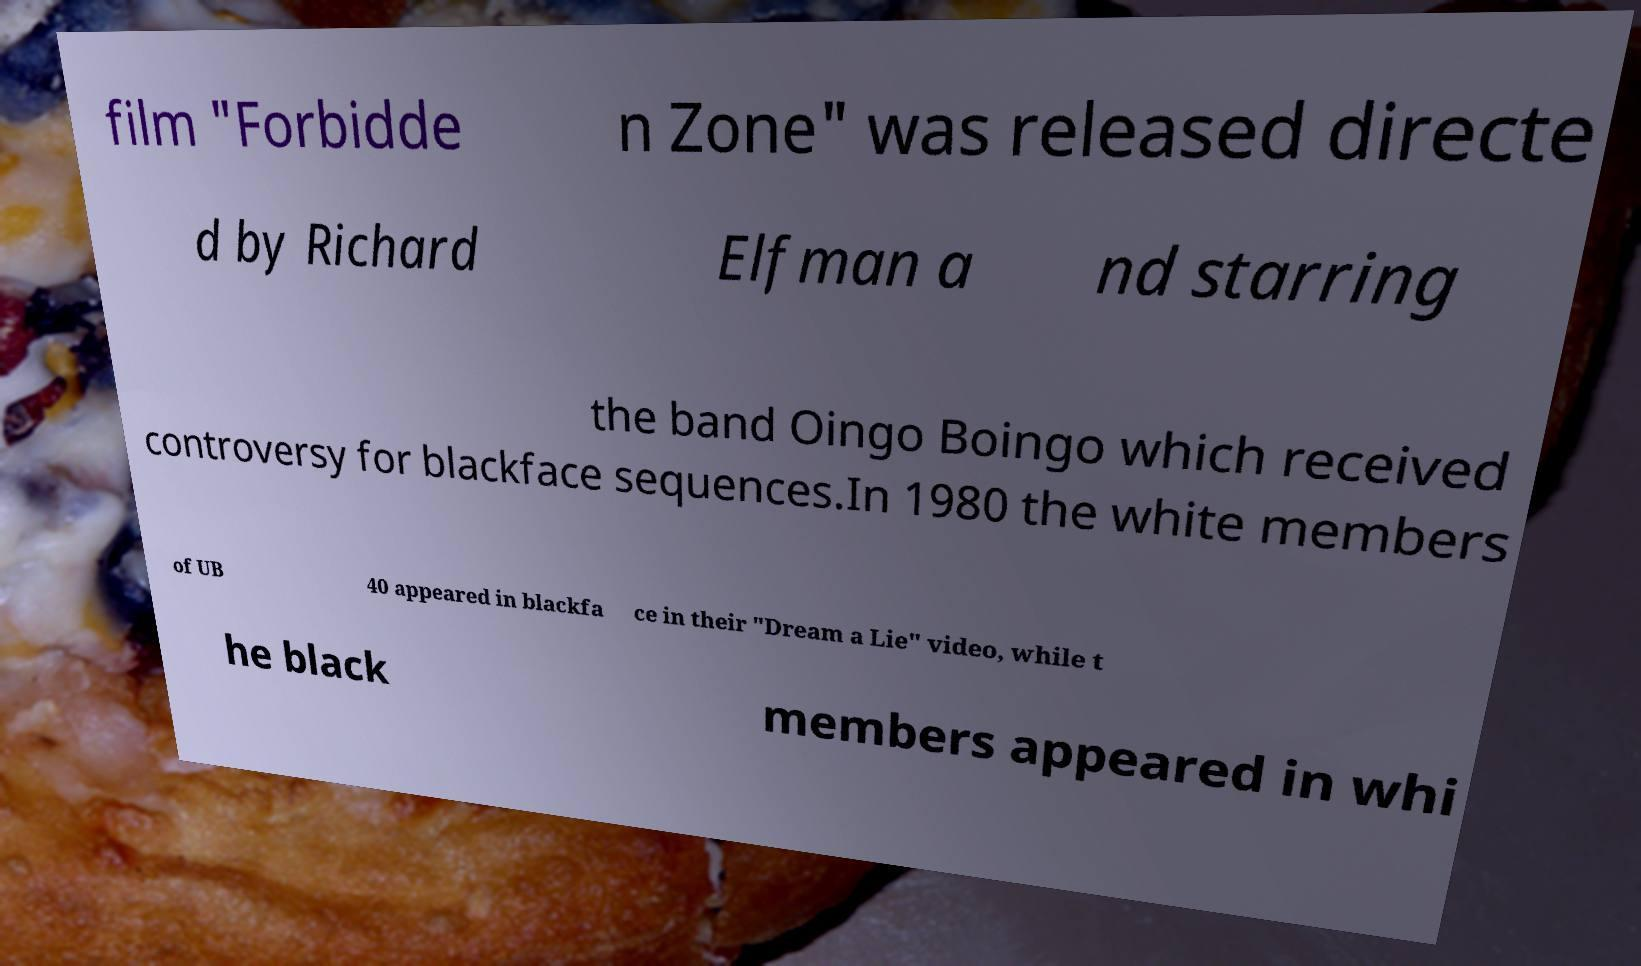There's text embedded in this image that I need extracted. Can you transcribe it verbatim? film "Forbidde n Zone" was released directe d by Richard Elfman a nd starring the band Oingo Boingo which received controversy for blackface sequences.In 1980 the white members of UB 40 appeared in blackfa ce in their "Dream a Lie" video, while t he black members appeared in whi 